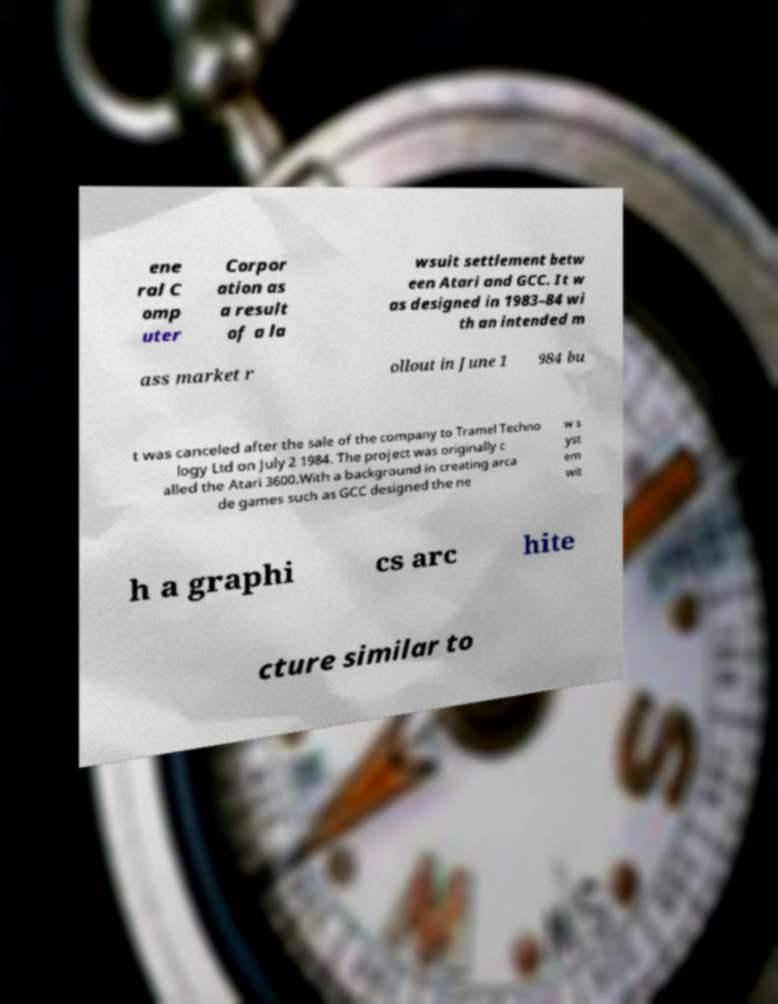There's text embedded in this image that I need extracted. Can you transcribe it verbatim? ene ral C omp uter Corpor ation as a result of a la wsuit settlement betw een Atari and GCC. It w as designed in 1983–84 wi th an intended m ass market r ollout in June 1 984 bu t was canceled after the sale of the company to Tramel Techno logy Ltd on July 2 1984. The project was originally c alled the Atari 3600.With a background in creating arca de games such as GCC designed the ne w s yst em wit h a graphi cs arc hite cture similar to 